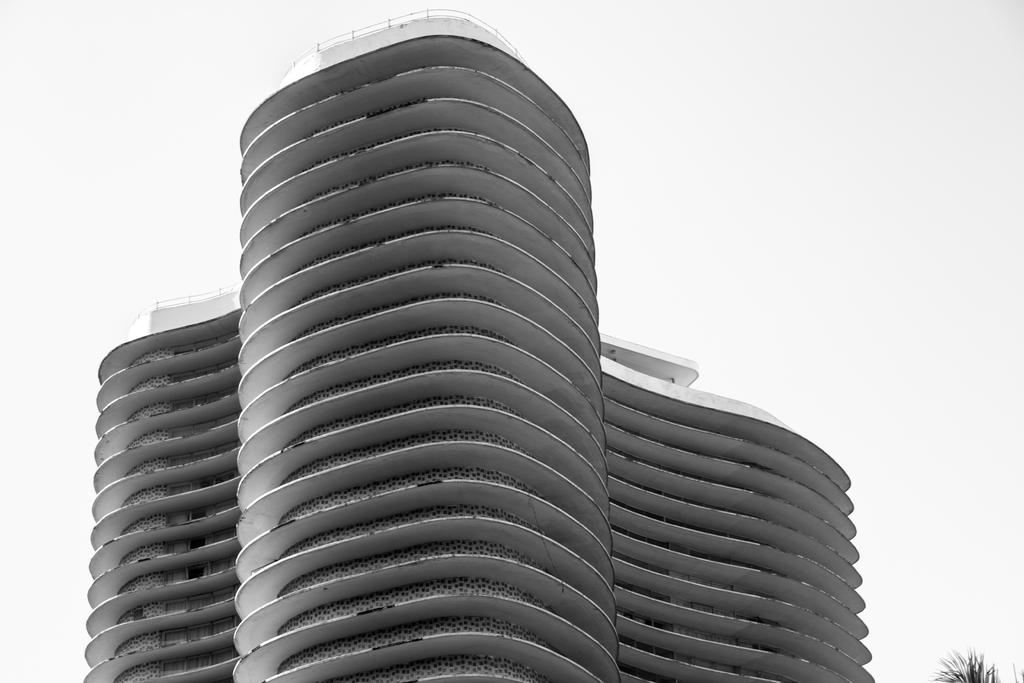What is the main structure in the image? There is a building in the image. What type of vegetation is on the right side of the image? There are plants on the right side of the image. What color is the background of the image? The background of the image is white. Can you see a bomb exploding in the image? No, there is no bomb or explosion present in the image. What type of stretch can be seen in the image? There is no stretch visible in the image; it features a building, plants, and a white background. 